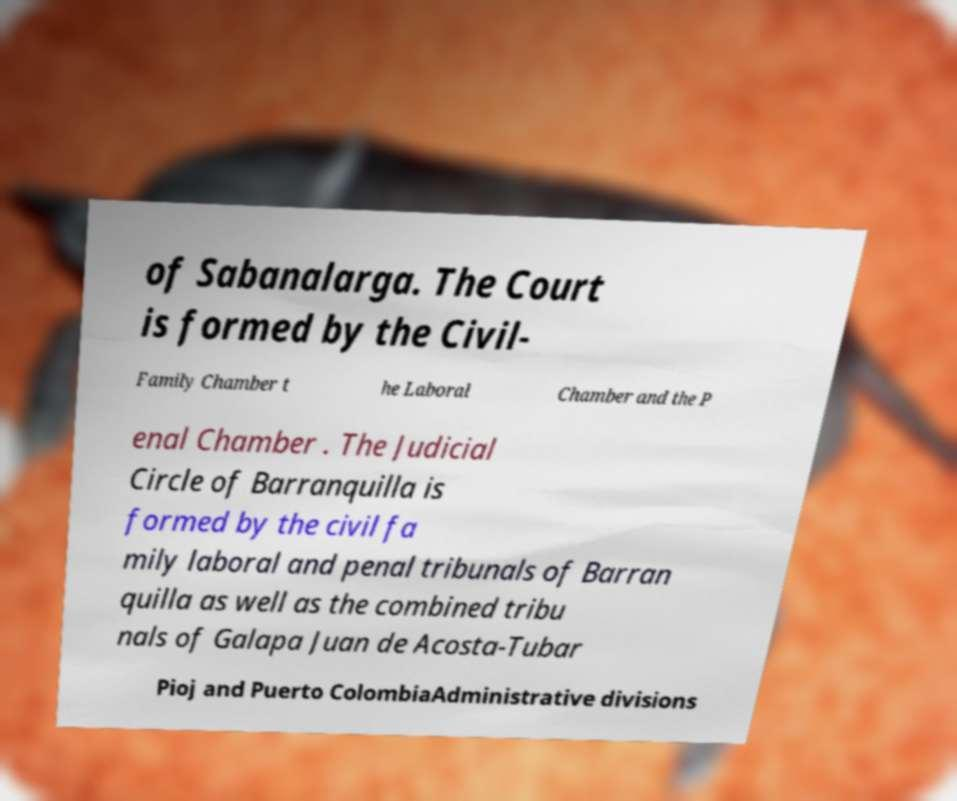Please identify and transcribe the text found in this image. of Sabanalarga. The Court is formed by the Civil- Family Chamber t he Laboral Chamber and the P enal Chamber . The Judicial Circle of Barranquilla is formed by the civil fa mily laboral and penal tribunals of Barran quilla as well as the combined tribu nals of Galapa Juan de Acosta-Tubar Pioj and Puerto ColombiaAdministrative divisions 